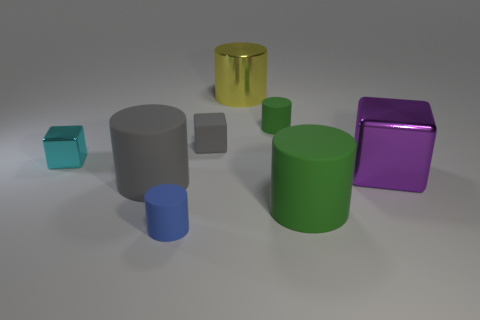What size is the cyan object?
Ensure brevity in your answer.  Small. What color is the big cylinder that is the same material as the big block?
Give a very brief answer. Yellow. What number of tiny gray blocks are the same material as the small blue thing?
Offer a very short reply. 1. Is the color of the large metallic cylinder the same as the tiny matte cylinder on the left side of the tiny green rubber object?
Provide a short and direct response. No. The big thing in front of the large matte cylinder to the left of the small green thing is what color?
Make the answer very short. Green. There is a metal object that is the same size as the yellow cylinder; what is its color?
Keep it short and to the point. Purple. Is there a green rubber object that has the same shape as the blue matte object?
Ensure brevity in your answer.  Yes. What is the shape of the large green object?
Your answer should be very brief. Cylinder. Is the number of green objects behind the gray cube greater than the number of small cyan metallic things in front of the purple shiny block?
Your response must be concise. Yes. There is a cube that is to the left of the big green matte cylinder and on the right side of the large gray cylinder; what is it made of?
Ensure brevity in your answer.  Rubber. 